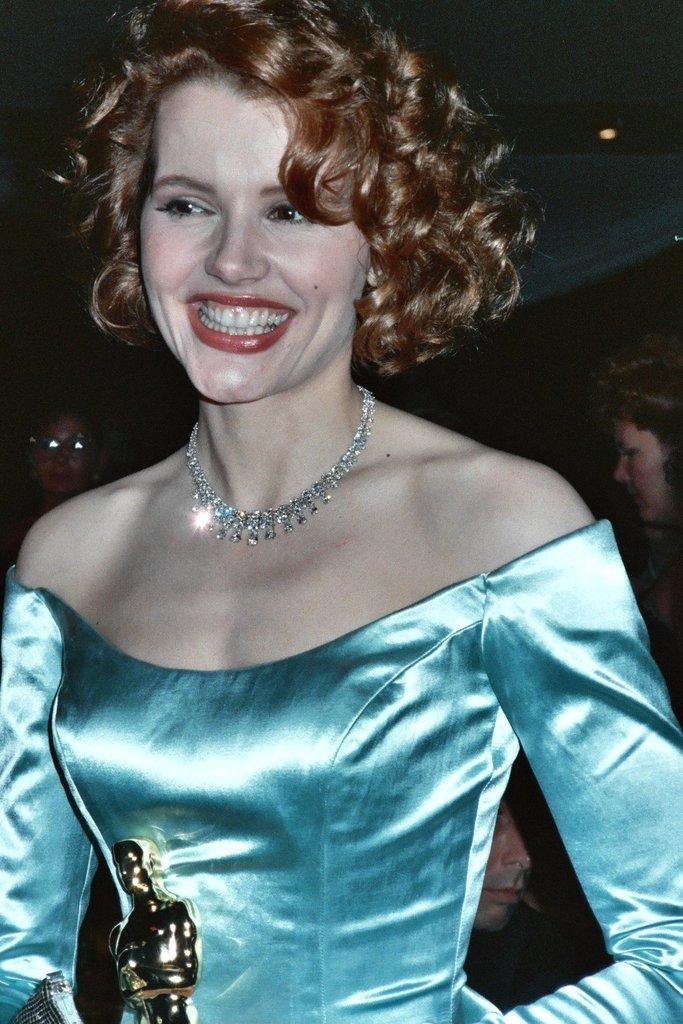Who is the main subject in the image? There is a lady in the image. Where is the lady positioned in the image? The lady is standing in the center of the image. Can you describe the background of the image? There are other people in the background of the image. What type of pail is the lady using to plough the field in the image? There is no pail or plough present in the image; it features a lady standing in the center with other people in the background. 